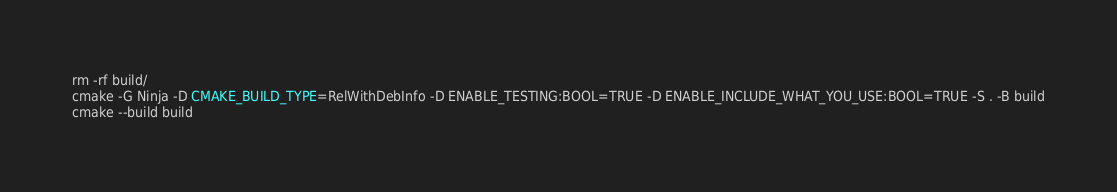Convert code to text. <code><loc_0><loc_0><loc_500><loc_500><_Bash_>rm -rf build/
cmake -G Ninja -D CMAKE_BUILD_TYPE=RelWithDebInfo -D ENABLE_TESTING:BOOL=TRUE -D ENABLE_INCLUDE_WHAT_YOU_USE:BOOL=TRUE -S . -B build
cmake --build build</code> 